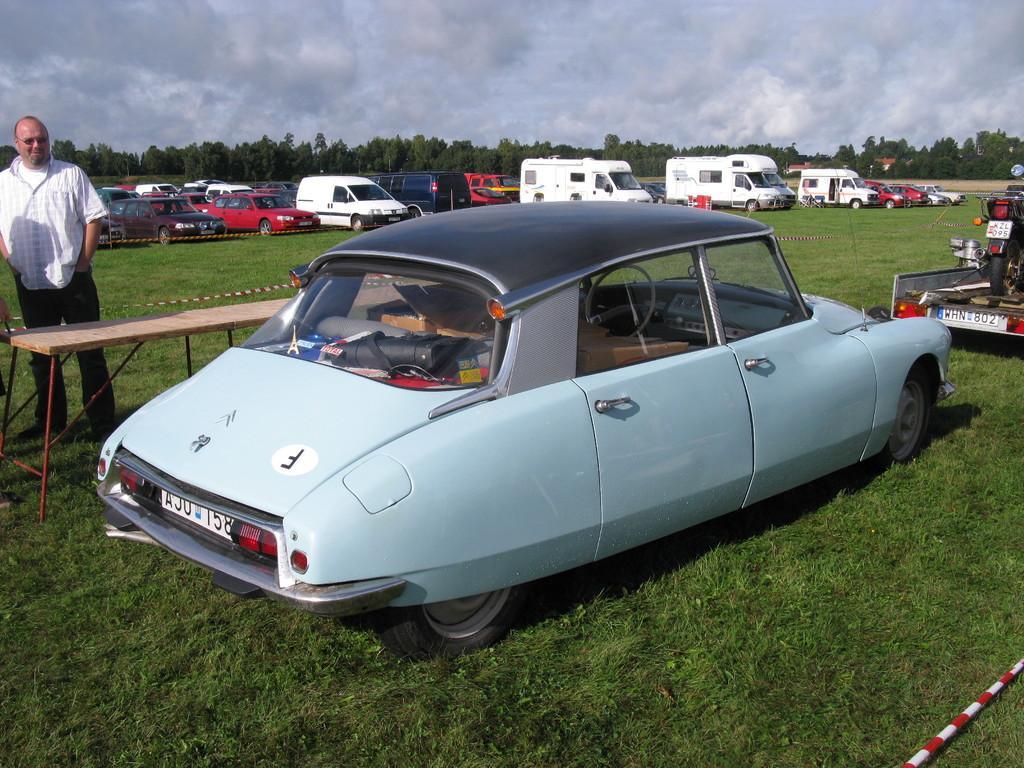In one or two sentences, can you explain what this image depicts? This picture is taken from the outside of the city. In this image, in the middle, we can see a car which is placed on the grass. On the right side, we can also see a vehicle. On the left side, we can see a man standing in front of the table. In the background, we can see few vehicles which are placed on the grass, road, trees, plants. At the top, we can see a sky which is cloudy, at the bottom, we can see a grass. In the right corner, we can see a rod. 